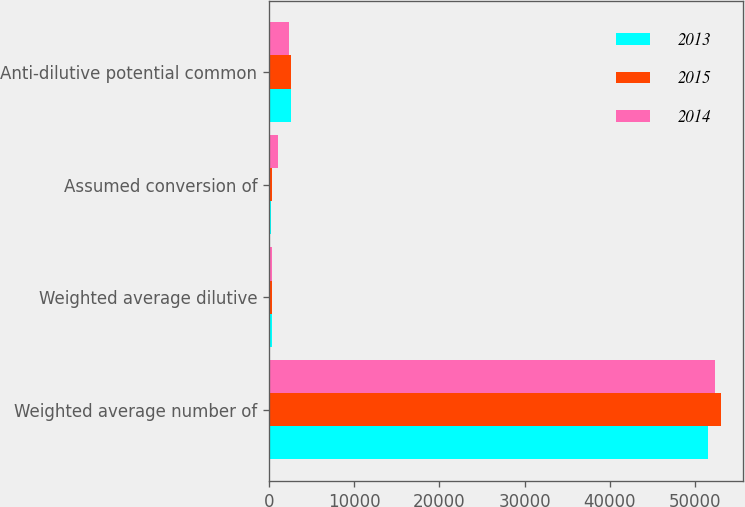Convert chart to OTSL. <chart><loc_0><loc_0><loc_500><loc_500><stacked_bar_chart><ecel><fcel>Weighted average number of<fcel>Weighted average dilutive<fcel>Assumed conversion of<fcel>Anti-dilutive potential common<nl><fcel>2013<fcel>51593<fcel>395<fcel>258<fcel>2563<nl><fcel>2015<fcel>53023<fcel>340<fcel>382<fcel>2574<nl><fcel>2014<fcel>52413<fcel>382<fcel>1107<fcel>2384<nl></chart> 